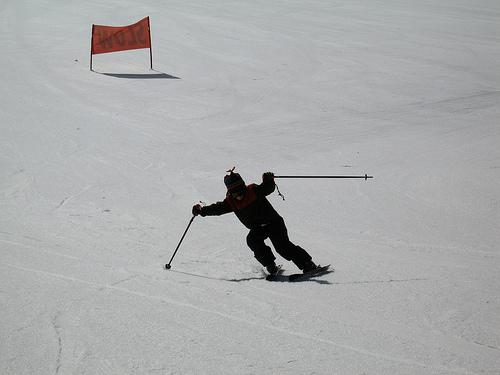Question: what sport is shown?
Choices:
A. Ice Skating.
B. Snowboarding.
C. Skiing.
D. Luge.
Answer with the letter. Answer: C Question: what are on the person's feet?
Choices:
A. Ice Skates.
B. Skis.
C. Snowboard.
D. Boots.
Answer with the letter. Answer: B Question: how many poles is the person holding?
Choices:
A. 2.
B. 3.
C. 4.
D. 5.
Answer with the letter. Answer: A 